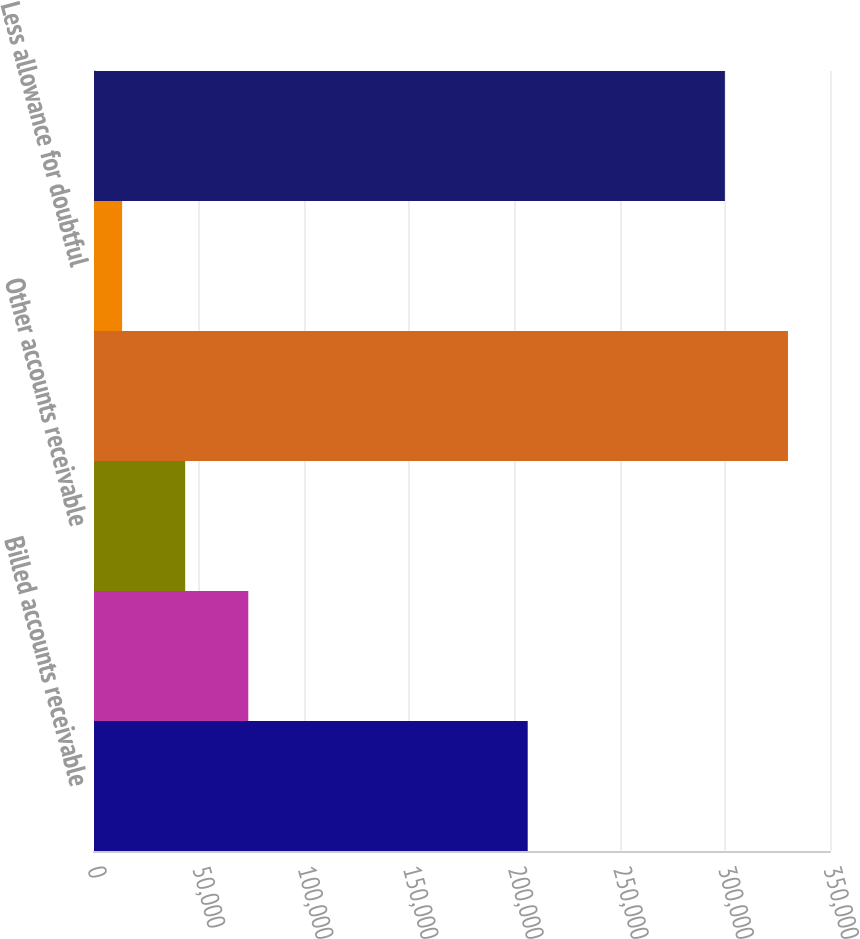<chart> <loc_0><loc_0><loc_500><loc_500><bar_chart><fcel>Billed accounts receivable<fcel>Unbilled revenue<fcel>Other accounts receivable<fcel>Total accounts receivable<fcel>Less allowance for doubtful<fcel>Net accounts receivable<nl><fcel>206248<fcel>73368.4<fcel>43367.7<fcel>330008<fcel>13367<fcel>300007<nl></chart> 